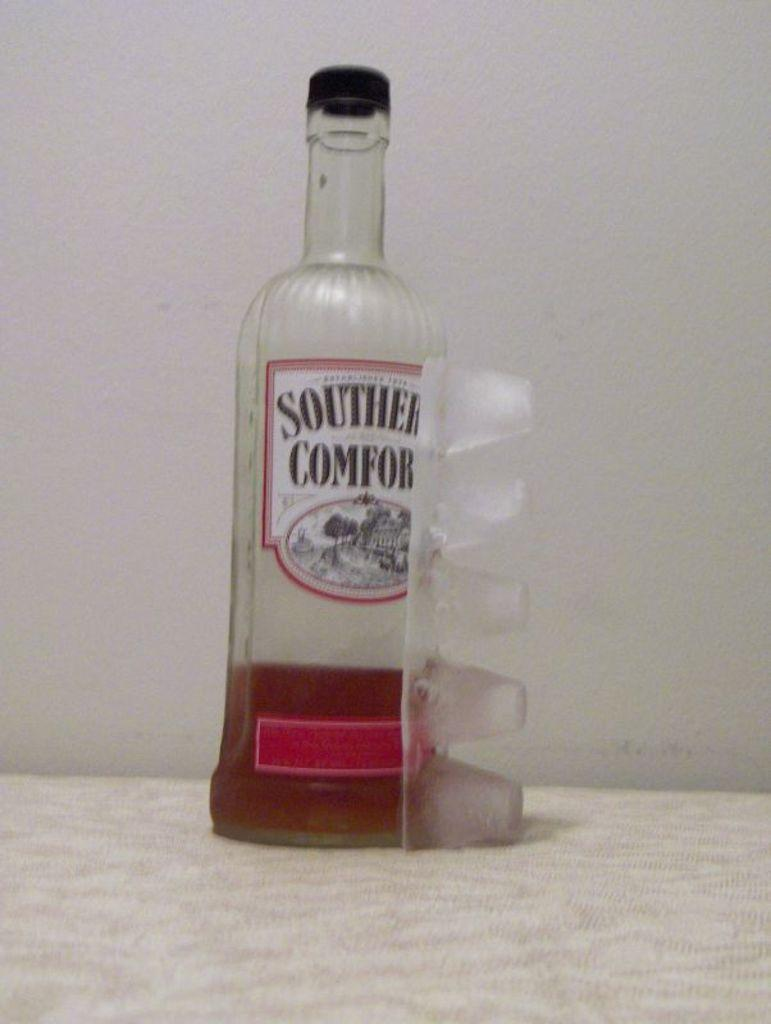What is in the bottle that is visible in the image? The bottle contains wine. Where is the bottle located in the image? The bottle is placed on a table. What type of argument is taking place between the basketball players in the image? There are no basketball players or arguments present in the image; it only features a bottle of wine on a table. 